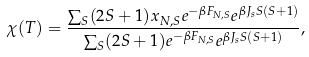<formula> <loc_0><loc_0><loc_500><loc_500>\chi ( T ) = \frac { \sum _ { S } ( 2 S + 1 ) x _ { N , S } e ^ { - \beta F _ { N , S } } e ^ { \beta J _ { s } S ( S + 1 ) } } { \sum _ { S } ( 2 S + 1 ) e ^ { - \beta F _ { N , S } } e ^ { \beta J _ { s } S ( S + 1 ) } } ,</formula> 